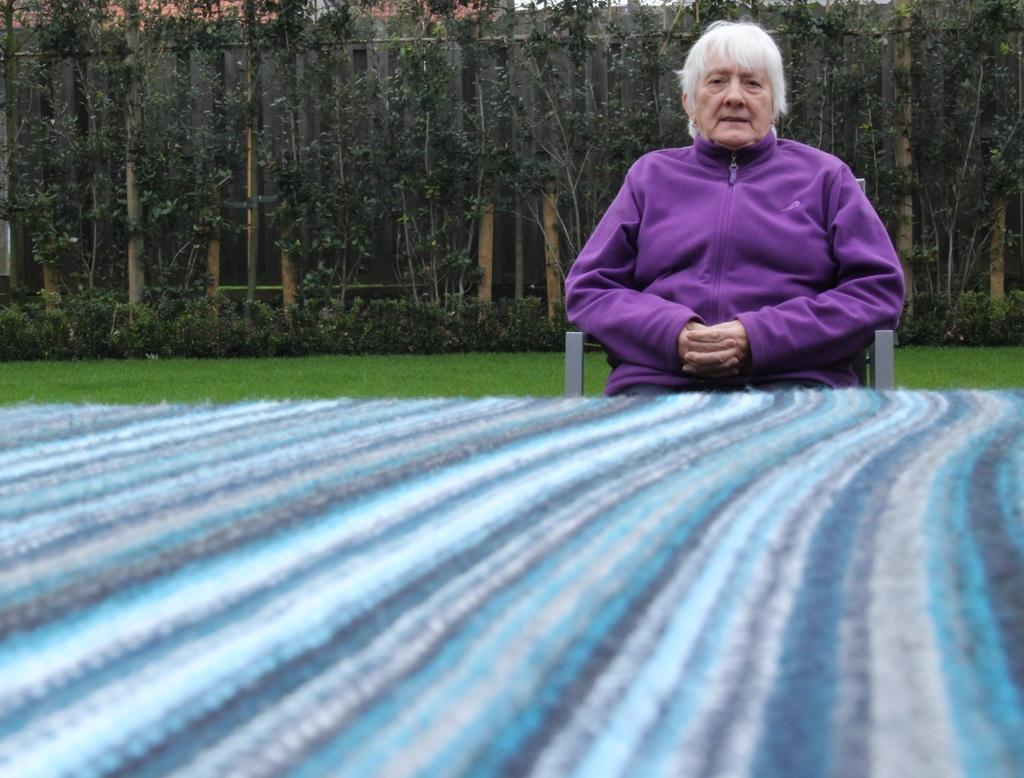What is the person in the image doing? The person is sitting on a chair in the image. What is the person wearing? The person is wearing a purple dress. What can be seen in the background of the image? There are trees visible in the background of the image. What is in front of the person? There is a multi-color board in front of the person. What type of creature is sitting on the ice in the image? There is no ice or creature present in the image. 